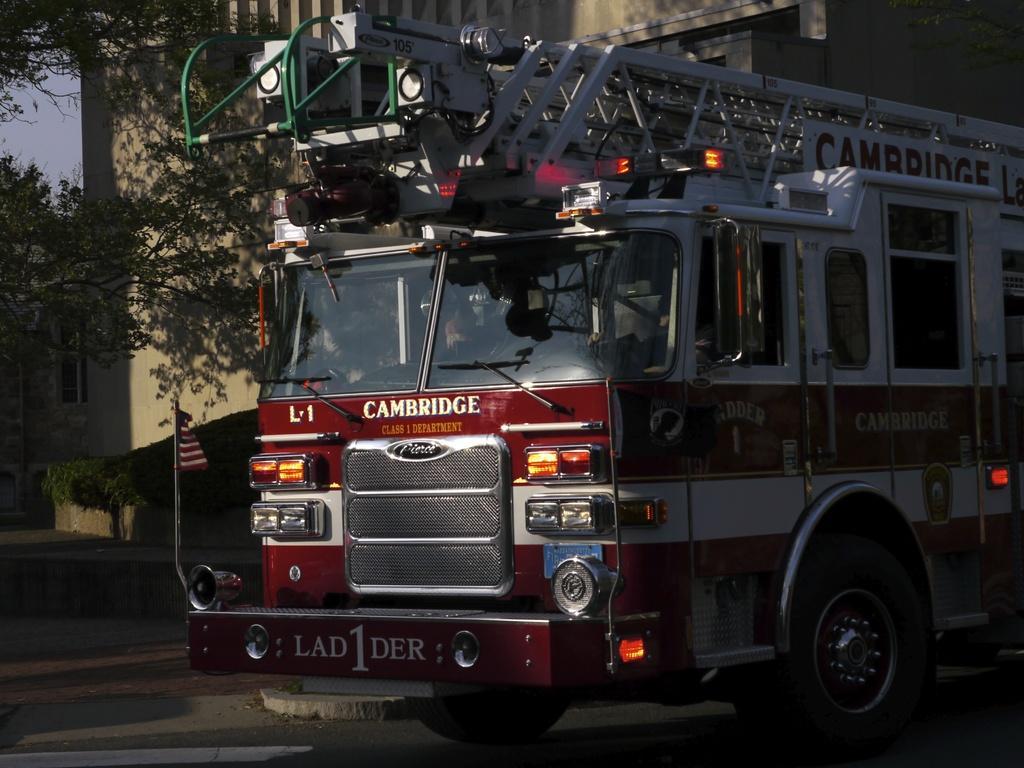How would you summarize this image in a sentence or two? This image consists of a truck in red color. At the bottom, there is a road. On the left, we can see the trees. In the background, there is a building. 